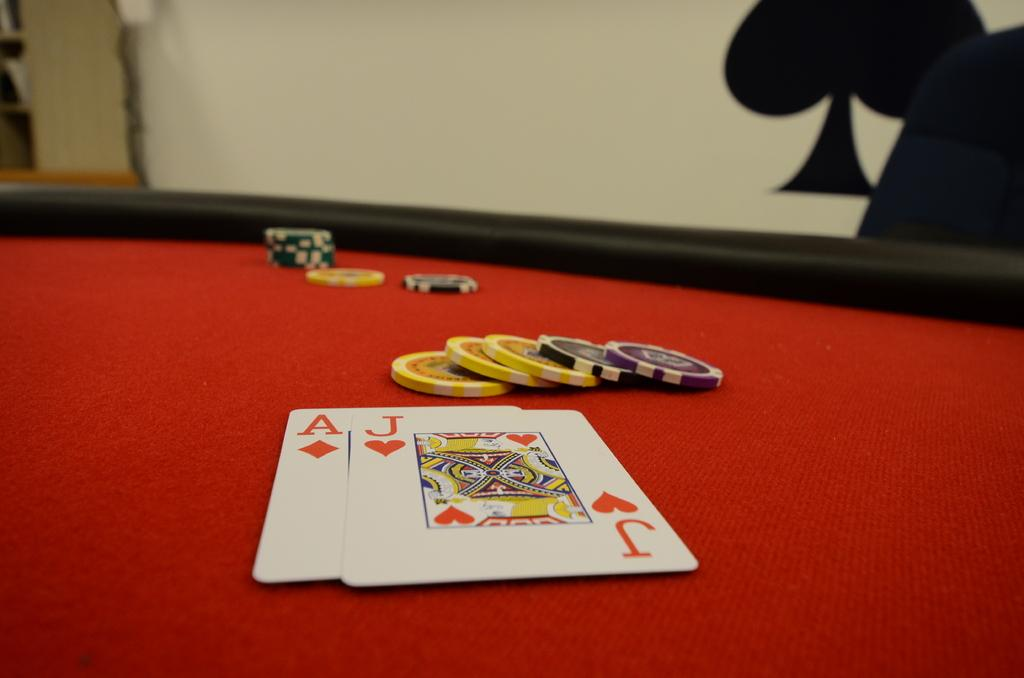What is the main object in the image? There is a board in the image. What is placed on the board? Two playing cards are on the board. Are there any other items near the cards? Yes, there are coins beside the cards. Can you describe any symbols or markings on the cards? There is a symbol on a card in the background. Reasoning: Let's: Let's think step by step in order to produce the conversation. We start by identifying the main object in the image, which is the board. Then, we describe the items placed on the board, which are the playing cards. Next, we mention the coins beside the cards as additional items in the image. Finally, we address the symbol on a card in the background, which provides more detail about the playing cards. Absurd Question/Answer: What type of eggnog is being served in the image? There is no eggnog present in the image. How many legs are visible in the image? The image does not show any legs; it features a board with playing cards and coins. 